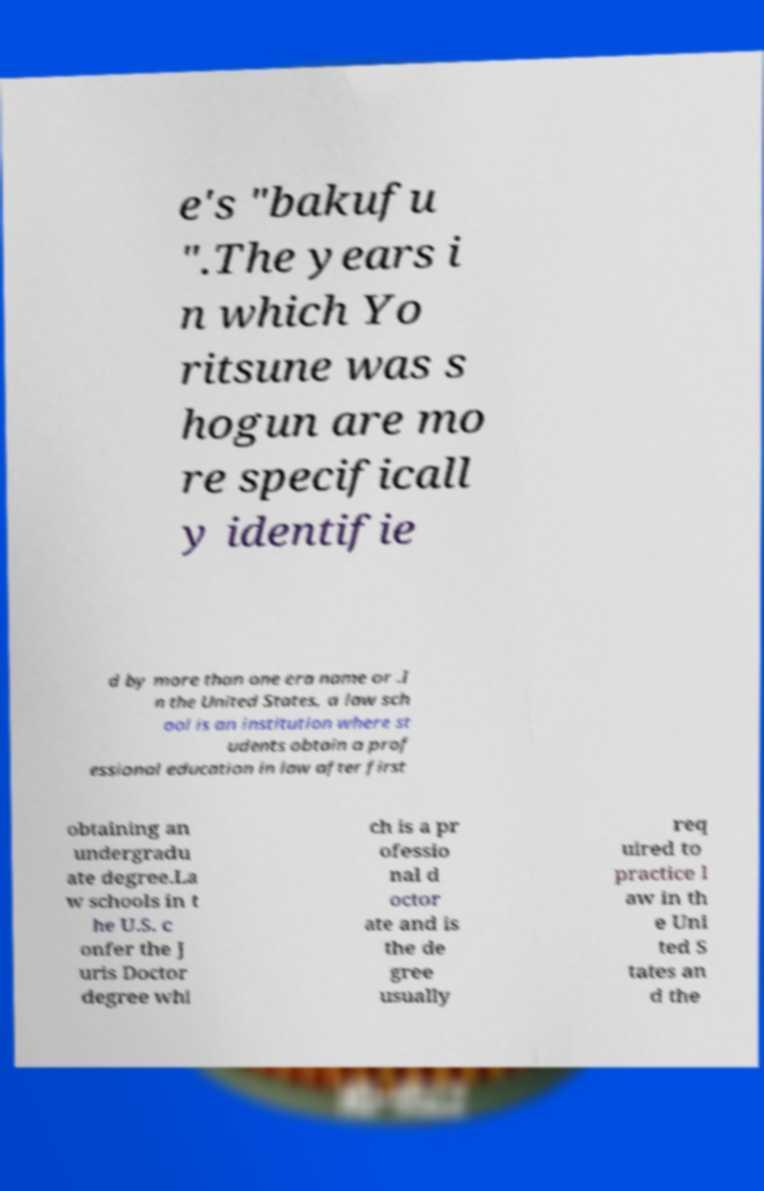I need the written content from this picture converted into text. Can you do that? e's "bakufu ".The years i n which Yo ritsune was s hogun are mo re specificall y identifie d by more than one era name or .I n the United States, a law sch ool is an institution where st udents obtain a prof essional education in law after first obtaining an undergradu ate degree.La w schools in t he U.S. c onfer the J uris Doctor degree whi ch is a pr ofessio nal d octor ate and is the de gree usually req uired to practice l aw in th e Uni ted S tates an d the 